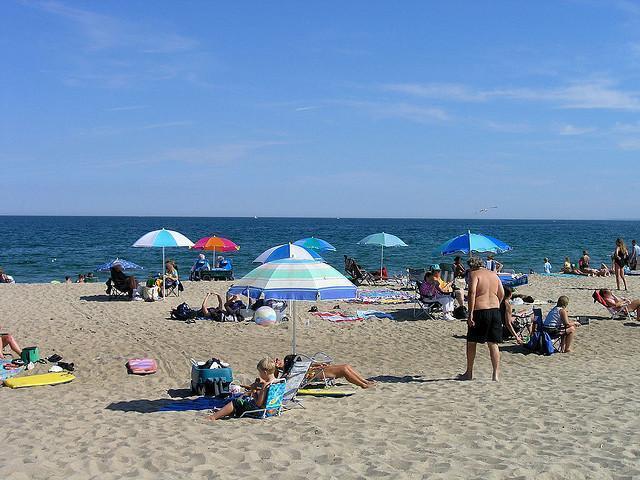How many umbrellas are there?
Give a very brief answer. 7. How many umbrellas are rainbow?
Give a very brief answer. 0. How many people can you see?
Give a very brief answer. 2. 